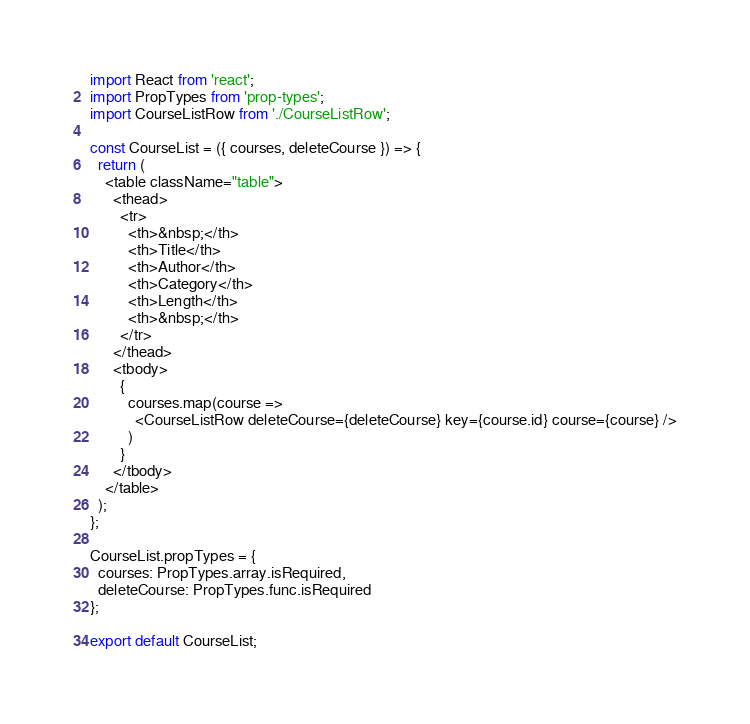Convert code to text. <code><loc_0><loc_0><loc_500><loc_500><_JavaScript_>import React from 'react';
import PropTypes from 'prop-types';
import CourseListRow from './CourseListRow';

const CourseList = ({ courses, deleteCourse }) => {
  return (
    <table className="table">
      <thead>
        <tr>
          <th>&nbsp;</th>
          <th>Title</th>
          <th>Author</th>
          <th>Category</th>
          <th>Length</th>
          <th>&nbsp;</th>
        </tr>
      </thead>
      <tbody>
        {
          courses.map(course =>
            <CourseListRow deleteCourse={deleteCourse} key={course.id} course={course} />
          )
        }
      </tbody>
    </table>
  );
};

CourseList.propTypes = {
  courses: PropTypes.array.isRequired,
  deleteCourse: PropTypes.func.isRequired
};

export default CourseList;</code> 